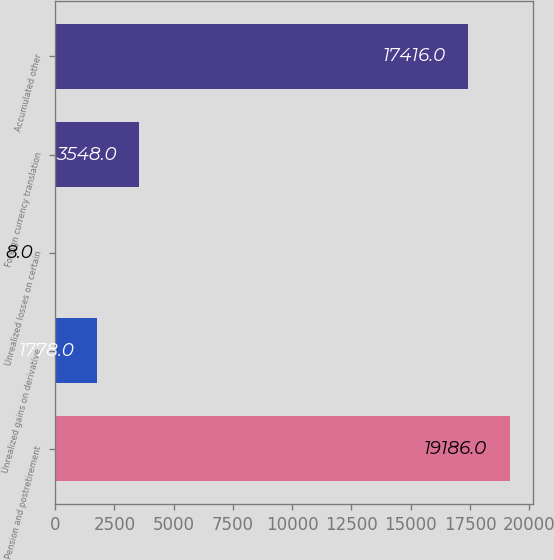<chart> <loc_0><loc_0><loc_500><loc_500><bar_chart><fcel>Pension and postretirement<fcel>Unrealized gains on derivative<fcel>Unrealized losses on certain<fcel>Foreign currency translation<fcel>Accumulated other<nl><fcel>19186<fcel>1778<fcel>8<fcel>3548<fcel>17416<nl></chart> 